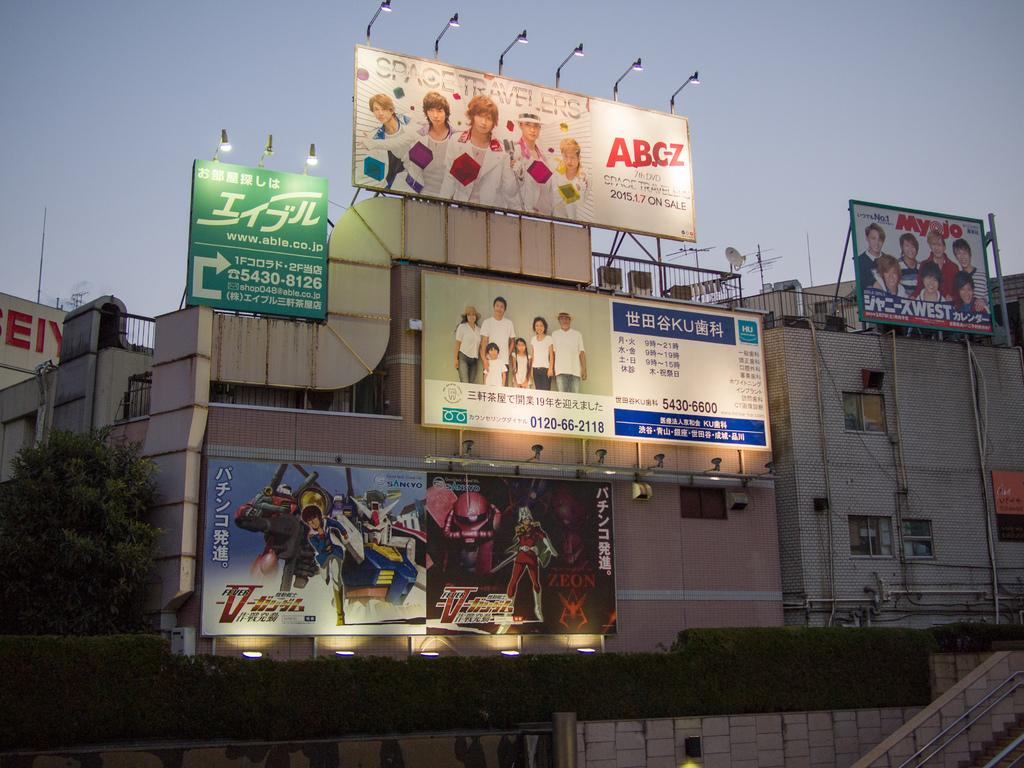What can be seen covering the walls in the image? There are many posters in the image. What is present in the image that separates spaces or provides a boundary? There is a fence in the image. What is providing illumination in the image? There are lights in the image. What type of natural element is present in the image? There is a tree in the image. What type of vegetation is present in the image besides the tree? There are plants in the image. What type of man-made structures are present in the image? There are buildings in the image. What part of the buildings can be seen in the image? There are windows of the building in the image. What architectural feature is present in the image that allows for vertical movement? There are stairs in the image. What is the color of the sky in the image? The sky is pale blue in the image. How many toes are visible on the posters in the image? There are no toes present on the posters in the image. What type of agricultural equipment is being used in the image? There is no agricultural equipment, such as a plough, present in the image. 